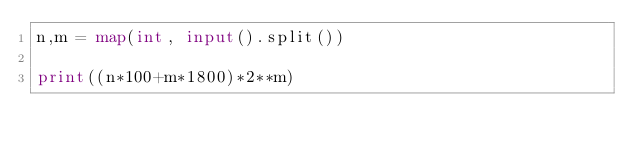Convert code to text. <code><loc_0><loc_0><loc_500><loc_500><_Python_>n,m = map(int, input().split())

print((n*100+m*1800)*2**m)</code> 